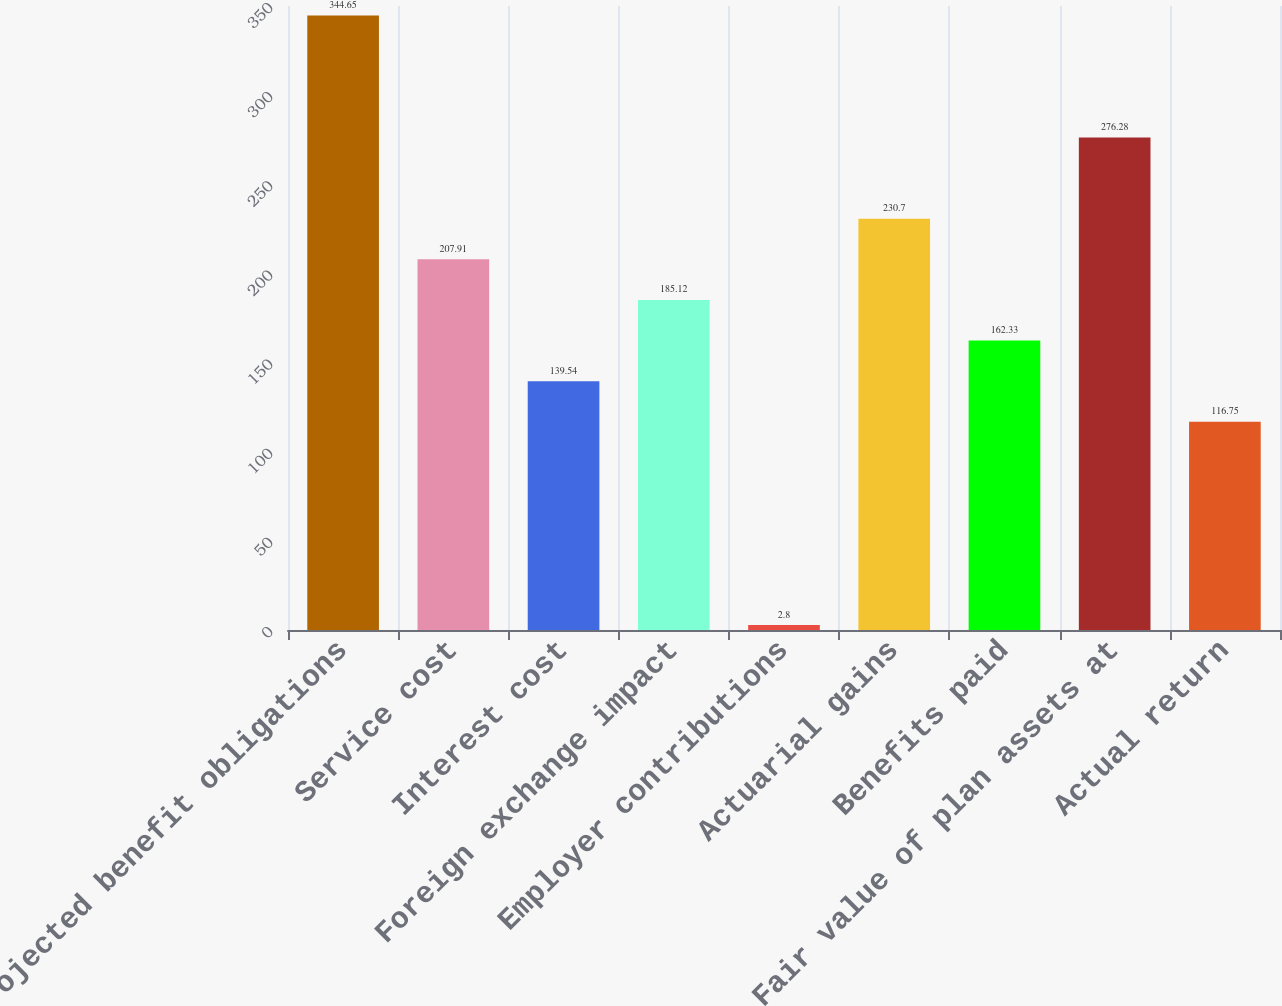Convert chart to OTSL. <chart><loc_0><loc_0><loc_500><loc_500><bar_chart><fcel>Projected benefit obligations<fcel>Service cost<fcel>Interest cost<fcel>Foreign exchange impact<fcel>Employer contributions<fcel>Actuarial gains<fcel>Benefits paid<fcel>Fair value of plan assets at<fcel>Actual return<nl><fcel>344.65<fcel>207.91<fcel>139.54<fcel>185.12<fcel>2.8<fcel>230.7<fcel>162.33<fcel>276.28<fcel>116.75<nl></chart> 